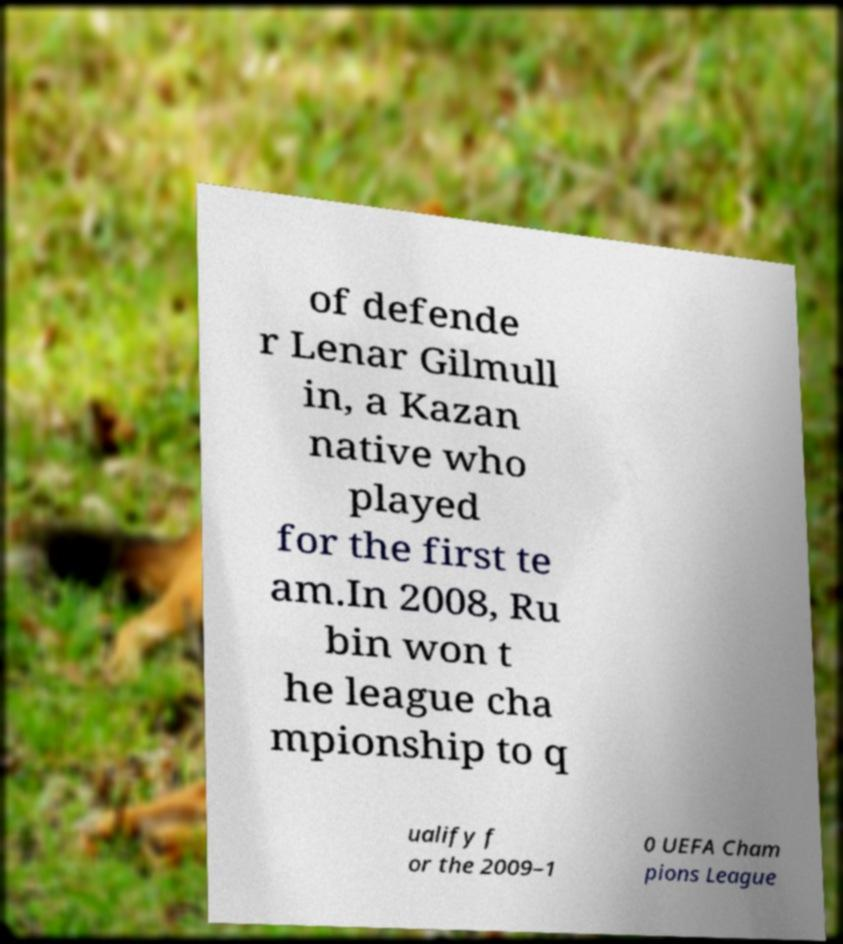I need the written content from this picture converted into text. Can you do that? of defende r Lenar Gilmull in, a Kazan native who played for the first te am.In 2008, Ru bin won t he league cha mpionship to q ualify f or the 2009–1 0 UEFA Cham pions League 